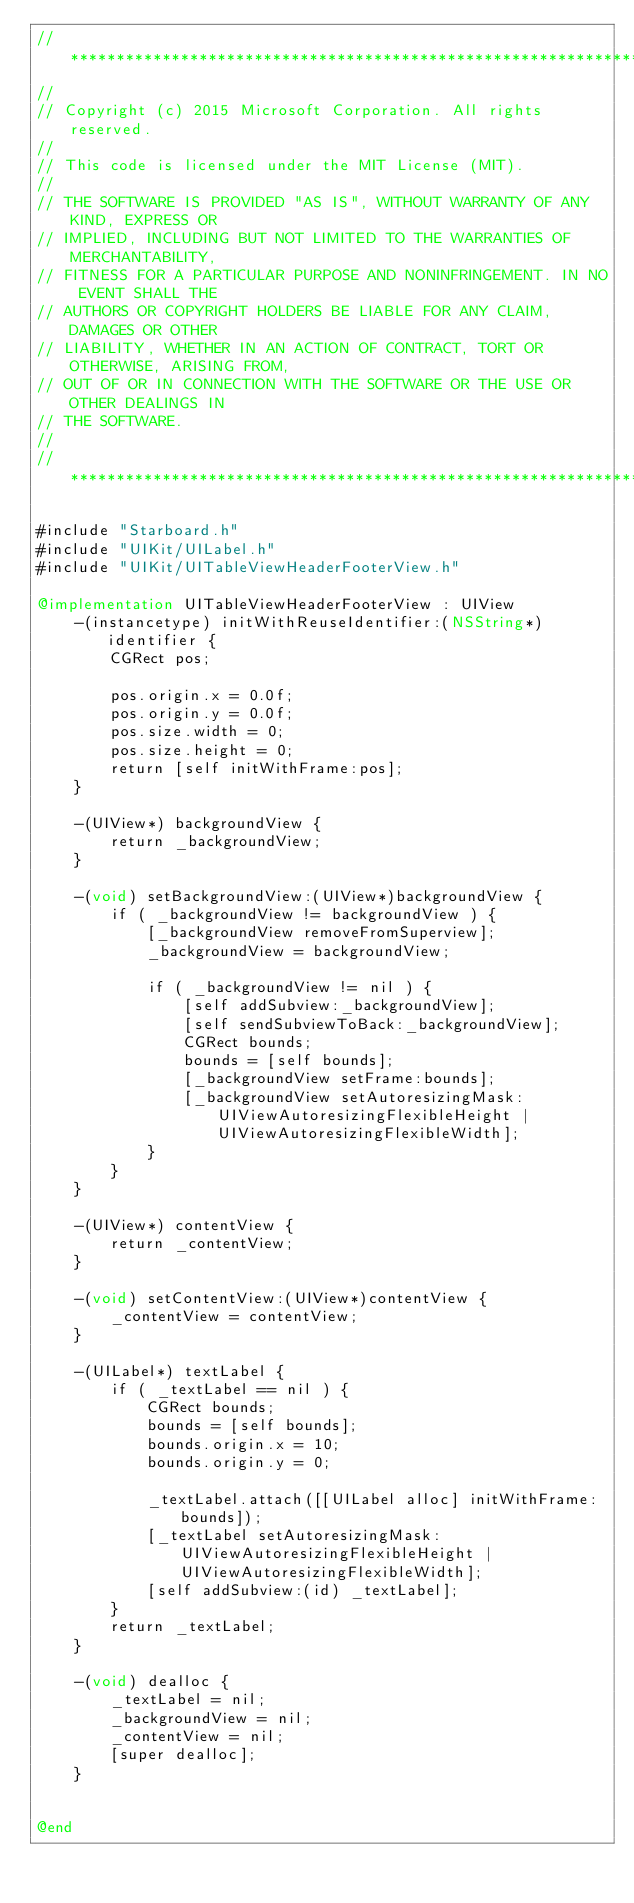<code> <loc_0><loc_0><loc_500><loc_500><_ObjectiveC_>//******************************************************************************
//
// Copyright (c) 2015 Microsoft Corporation. All rights reserved.
//
// This code is licensed under the MIT License (MIT).
//
// THE SOFTWARE IS PROVIDED "AS IS", WITHOUT WARRANTY OF ANY KIND, EXPRESS OR
// IMPLIED, INCLUDING BUT NOT LIMITED TO THE WARRANTIES OF MERCHANTABILITY,
// FITNESS FOR A PARTICULAR PURPOSE AND NONINFRINGEMENT. IN NO EVENT SHALL THE
// AUTHORS OR COPYRIGHT HOLDERS BE LIABLE FOR ANY CLAIM, DAMAGES OR OTHER
// LIABILITY, WHETHER IN AN ACTION OF CONTRACT, TORT OR OTHERWISE, ARISING FROM,
// OUT OF OR IN CONNECTION WITH THE SOFTWARE OR THE USE OR OTHER DEALINGS IN
// THE SOFTWARE.
//
//******************************************************************************

#include "Starboard.h"
#include "UIKit/UILabel.h"
#include "UIKit/UITableViewHeaderFooterView.h"

@implementation UITableViewHeaderFooterView : UIView
    -(instancetype) initWithReuseIdentifier:(NSString*)identifier {
        CGRect pos;

        pos.origin.x = 0.0f;
        pos.origin.y = 0.0f;
        pos.size.width = 0;
        pos.size.height = 0;
        return [self initWithFrame:pos];
    }

    -(UIView*) backgroundView {
        return _backgroundView;
    }

    -(void) setBackgroundView:(UIView*)backgroundView {
        if ( _backgroundView != backgroundView ) {
            [_backgroundView removeFromSuperview];
            _backgroundView = backgroundView;

            if ( _backgroundView != nil ) {
                [self addSubview:_backgroundView];
                [self sendSubviewToBack:_backgroundView];
                CGRect bounds;
                bounds = [self bounds];
                [_backgroundView setFrame:bounds];
                [_backgroundView setAutoresizingMask:UIViewAutoresizingFlexibleHeight | UIViewAutoresizingFlexibleWidth];
            }
        }
    }

    -(UIView*) contentView {
        return _contentView;
    }

    -(void) setContentView:(UIView*)contentView {
        _contentView = contentView;
    }

    -(UILabel*) textLabel {
        if ( _textLabel == nil ) {
            CGRect bounds;
            bounds = [self bounds];
            bounds.origin.x = 10;
            bounds.origin.y = 0;

            _textLabel.attach([[UILabel alloc] initWithFrame:bounds]);
            [_textLabel setAutoresizingMask:UIViewAutoresizingFlexibleHeight | UIViewAutoresizingFlexibleWidth];
            [self addSubview:(id) _textLabel];
        }
        return _textLabel;
    }

    -(void) dealloc {
        _textLabel = nil;
        _backgroundView = nil;
        _contentView = nil;
        [super dealloc];
    }

    
@end

</code> 